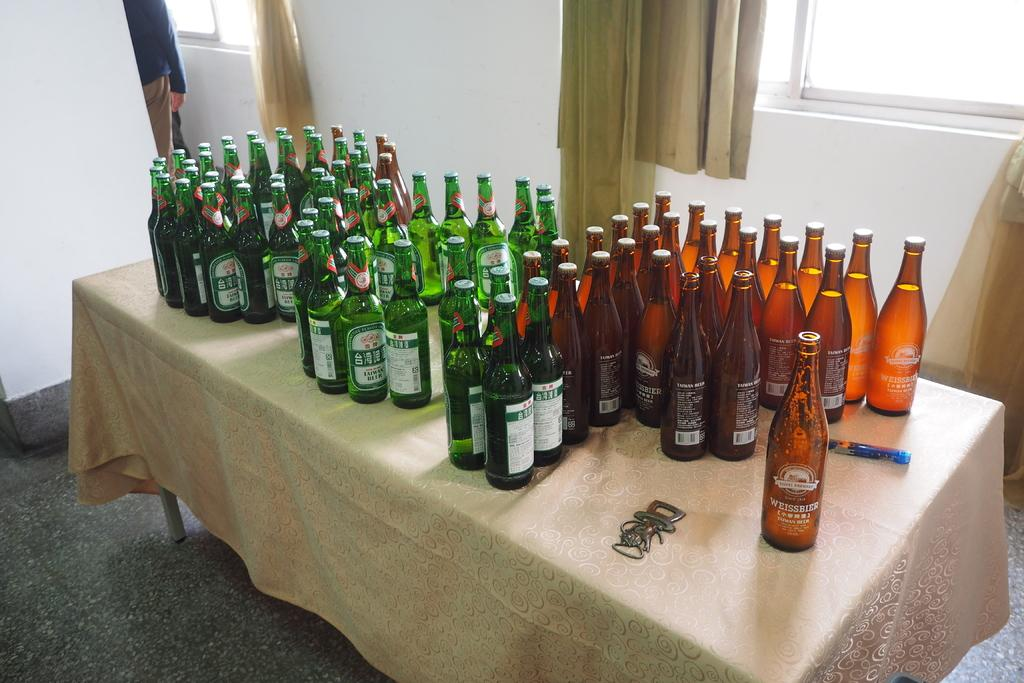<image>
Share a concise interpretation of the image provided. Bunch of bottles on a talbe some in circles and one says Weissbier. 